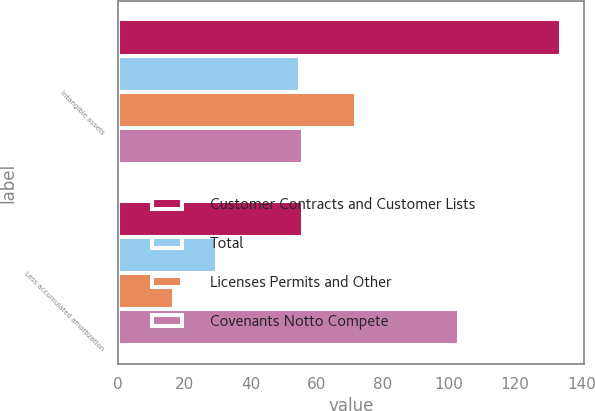Convert chart. <chart><loc_0><loc_0><loc_500><loc_500><stacked_bar_chart><ecel><fcel>Intangible assets<fcel>Less accumulated amortization<nl><fcel>Customer Contracts and Customer Lists<fcel>134<fcel>56<nl><fcel>Total<fcel>55<fcel>30<nl><fcel>Licenses Permits and Other<fcel>72<fcel>17<nl><fcel>Covenants Notto Compete<fcel>56<fcel>103<nl></chart> 